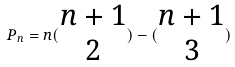Convert formula to latex. <formula><loc_0><loc_0><loc_500><loc_500>P _ { n } = n ( \begin{matrix} n + 1 \\ 2 \end{matrix} ) - ( \begin{matrix} n + 1 \\ 3 \end{matrix} )</formula> 